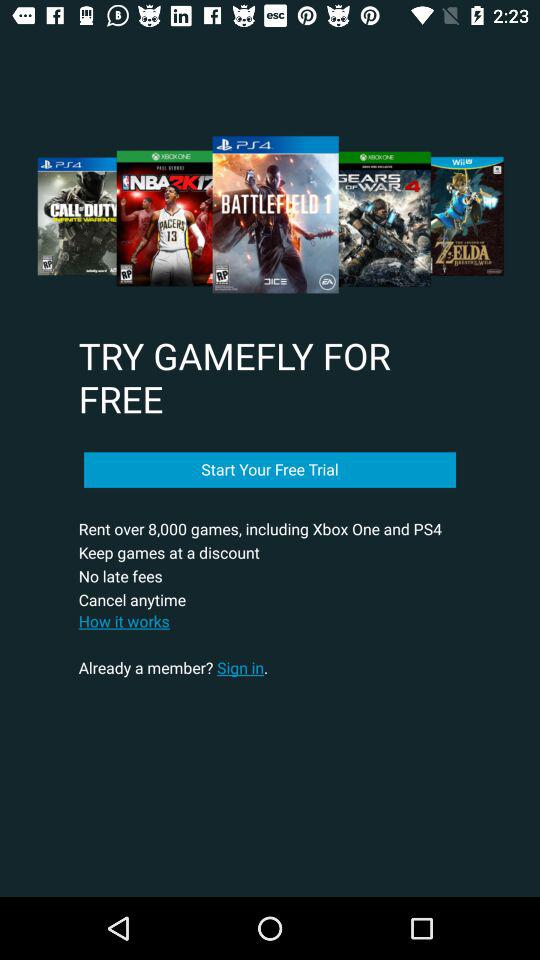How many games can we rent? You can rent 8000 games. 